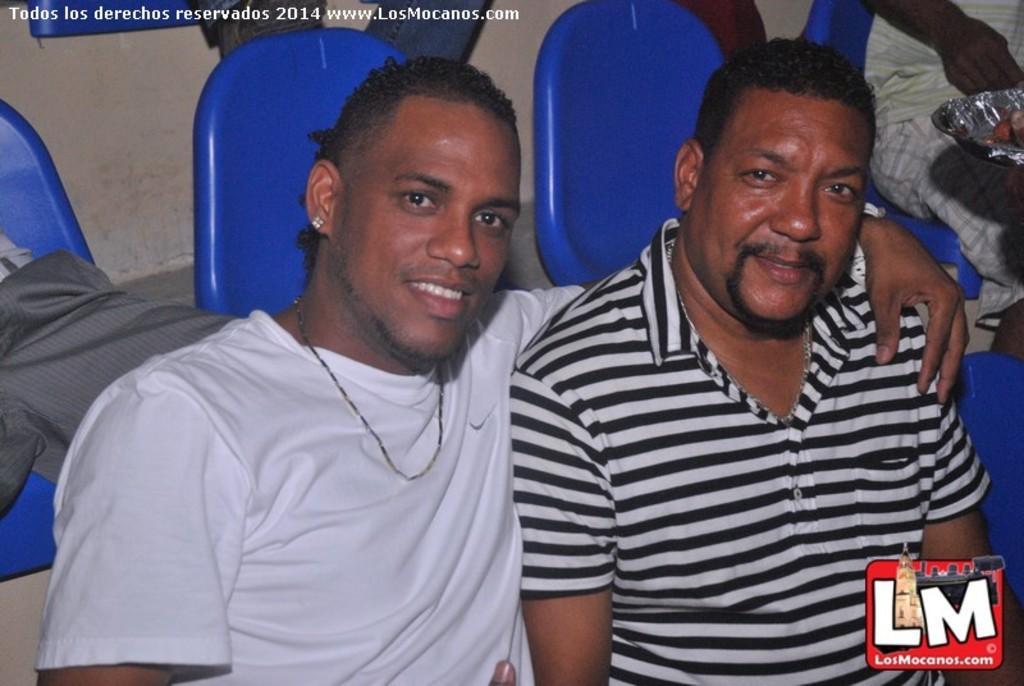Please provide a concise description of this image. In the picture I can see people are sitting among them these two men sitting in front are smiling. In the background I can see in blue color chairs and some other objects. I can also see watermarks on the image. 